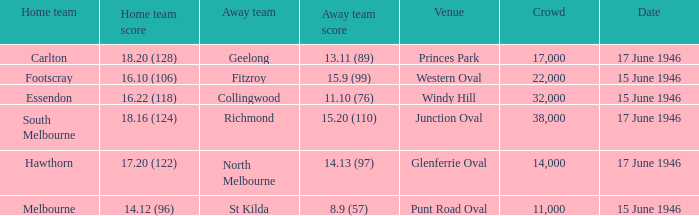On what date did a home team score 16.10 (106)? 15 June 1946. 